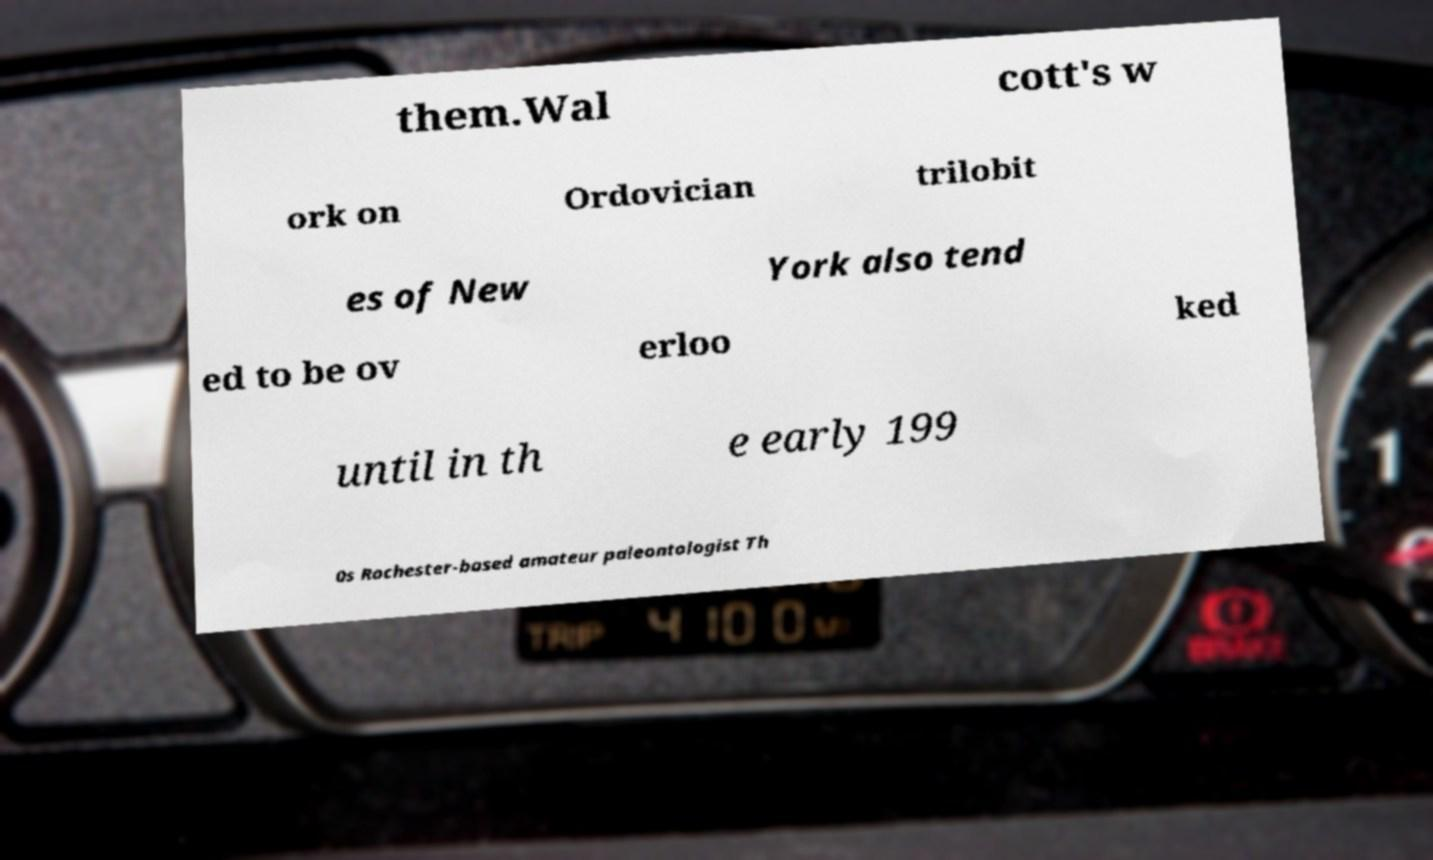For documentation purposes, I need the text within this image transcribed. Could you provide that? them.Wal cott's w ork on Ordovician trilobit es of New York also tend ed to be ov erloo ked until in th e early 199 0s Rochester-based amateur paleontologist Th 